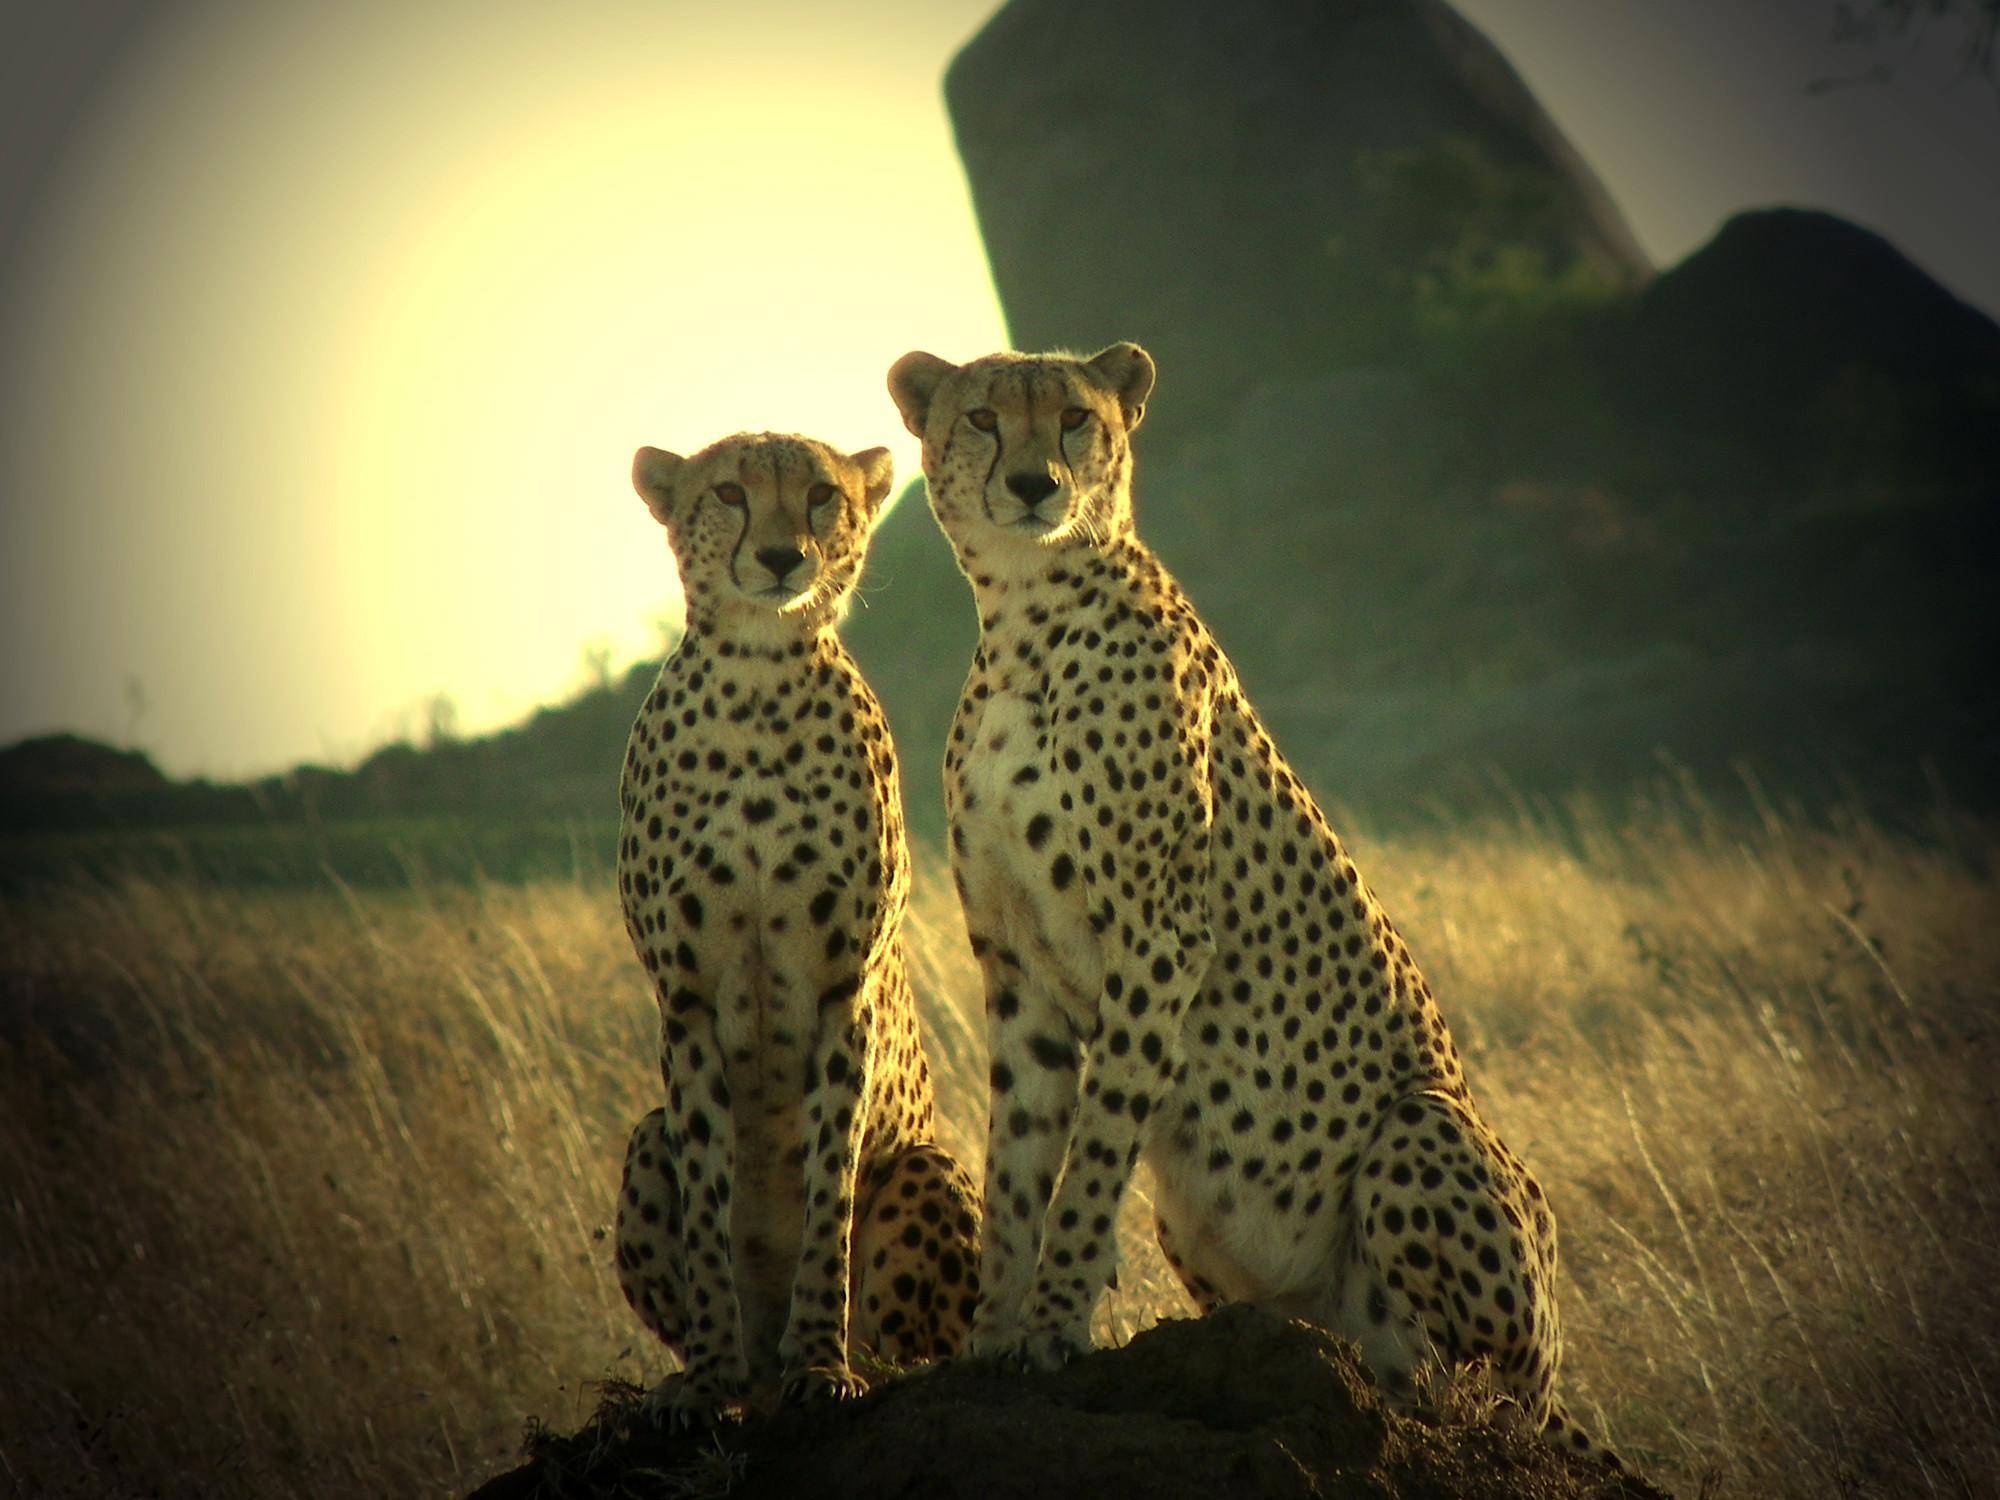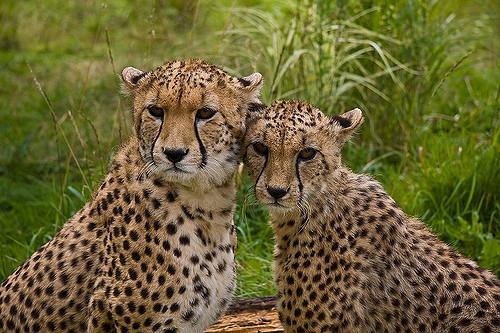The first image is the image on the left, the second image is the image on the right. Evaluate the accuracy of this statement regarding the images: "One image has two Cheetahs with one licking the other.". Is it true? Answer yes or no. No. 